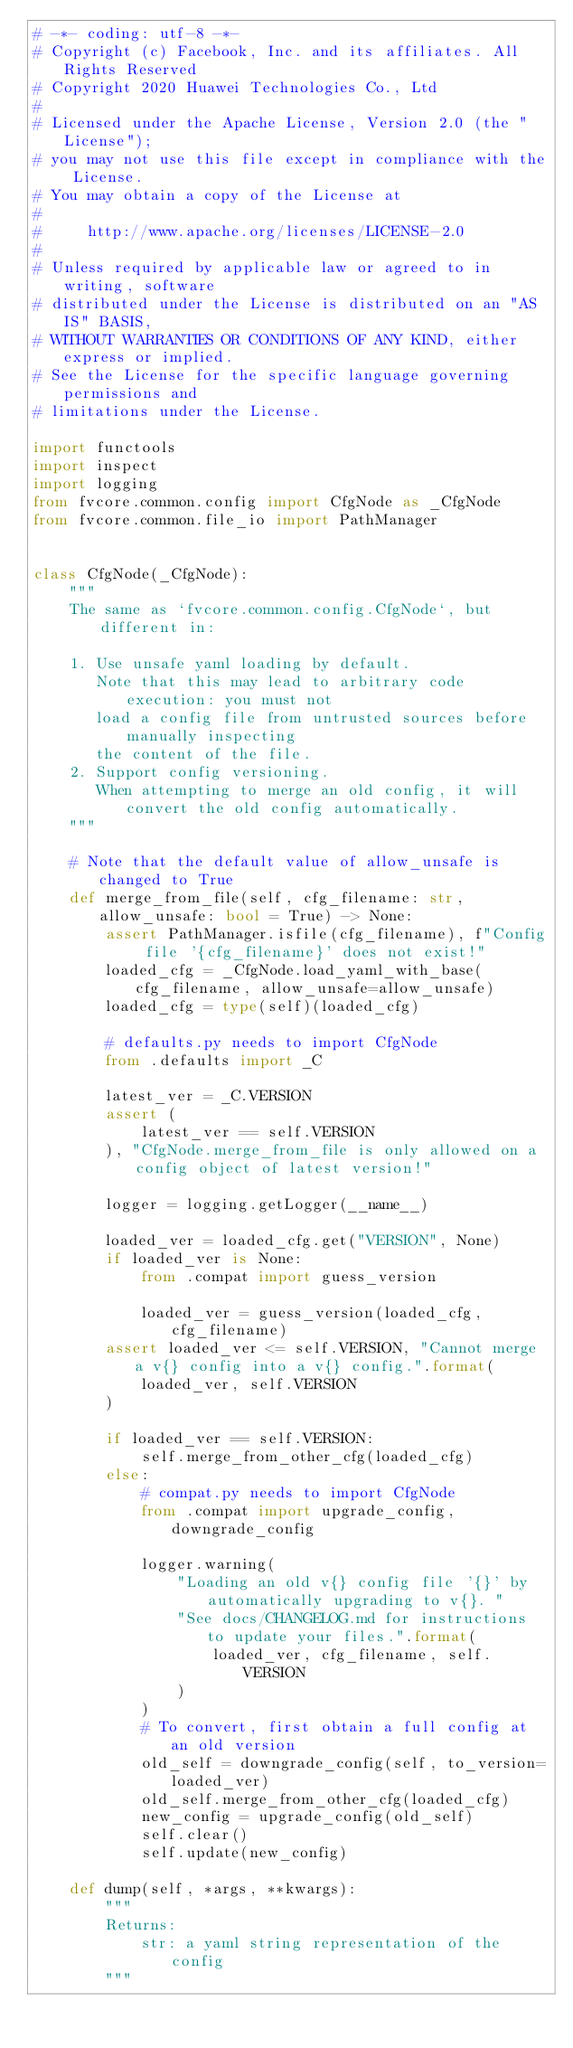Convert code to text. <code><loc_0><loc_0><loc_500><loc_500><_Python_># -*- coding: utf-8 -*-
# Copyright (c) Facebook, Inc. and its affiliates. All Rights Reserved
# Copyright 2020 Huawei Technologies Co., Ltd
#
# Licensed under the Apache License, Version 2.0 (the "License");
# you may not use this file except in compliance with the License.
# You may obtain a copy of the License at
#
#     http://www.apache.org/licenses/LICENSE-2.0
#
# Unless required by applicable law or agreed to in writing, software
# distributed under the License is distributed on an "AS IS" BASIS,
# WITHOUT WARRANTIES OR CONDITIONS OF ANY KIND, either express or implied.
# See the License for the specific language governing permissions and
# limitations under the License.

import functools
import inspect
import logging
from fvcore.common.config import CfgNode as _CfgNode
from fvcore.common.file_io import PathManager


class CfgNode(_CfgNode):
    """
    The same as `fvcore.common.config.CfgNode`, but different in:

    1. Use unsafe yaml loading by default.
       Note that this may lead to arbitrary code execution: you must not
       load a config file from untrusted sources before manually inspecting
       the content of the file.
    2. Support config versioning.
       When attempting to merge an old config, it will convert the old config automatically.
    """

    # Note that the default value of allow_unsafe is changed to True
    def merge_from_file(self, cfg_filename: str, allow_unsafe: bool = True) -> None:
        assert PathManager.isfile(cfg_filename), f"Config file '{cfg_filename}' does not exist!"
        loaded_cfg = _CfgNode.load_yaml_with_base(cfg_filename, allow_unsafe=allow_unsafe)
        loaded_cfg = type(self)(loaded_cfg)

        # defaults.py needs to import CfgNode
        from .defaults import _C

        latest_ver = _C.VERSION
        assert (
            latest_ver == self.VERSION
        ), "CfgNode.merge_from_file is only allowed on a config object of latest version!"

        logger = logging.getLogger(__name__)

        loaded_ver = loaded_cfg.get("VERSION", None)
        if loaded_ver is None:
            from .compat import guess_version

            loaded_ver = guess_version(loaded_cfg, cfg_filename)
        assert loaded_ver <= self.VERSION, "Cannot merge a v{} config into a v{} config.".format(
            loaded_ver, self.VERSION
        )

        if loaded_ver == self.VERSION:
            self.merge_from_other_cfg(loaded_cfg)
        else:
            # compat.py needs to import CfgNode
            from .compat import upgrade_config, downgrade_config

            logger.warning(
                "Loading an old v{} config file '{}' by automatically upgrading to v{}. "
                "See docs/CHANGELOG.md for instructions to update your files.".format(
                    loaded_ver, cfg_filename, self.VERSION
                )
            )
            # To convert, first obtain a full config at an old version
            old_self = downgrade_config(self, to_version=loaded_ver)
            old_self.merge_from_other_cfg(loaded_cfg)
            new_config = upgrade_config(old_self)
            self.clear()
            self.update(new_config)

    def dump(self, *args, **kwargs):
        """
        Returns:
            str: a yaml string representation of the config
        """</code> 